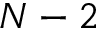<formula> <loc_0><loc_0><loc_500><loc_500>N - 2</formula> 